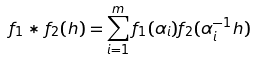Convert formula to latex. <formula><loc_0><loc_0><loc_500><loc_500>f _ { 1 } * f _ { 2 } ( h ) = \sum _ { i = 1 } ^ { m } f _ { 1 } ( \alpha _ { i } ) f _ { 2 } ( \alpha _ { i } ^ { - 1 } h )</formula> 